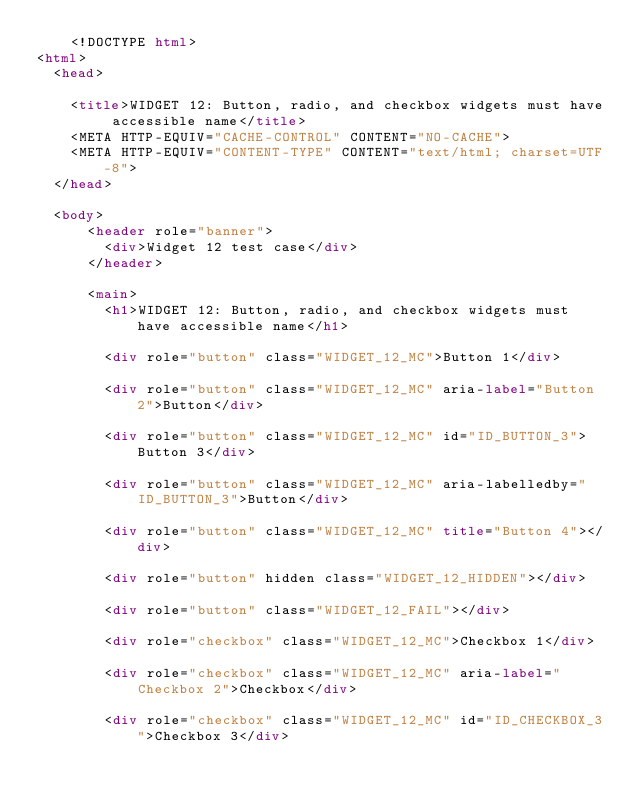<code> <loc_0><loc_0><loc_500><loc_500><_HTML_>    <!DOCTYPE html>
<html>
  <head>
    
    <title>WIDGET 12: Button, radio, and checkbox widgets must have accessible name</title>
    <META HTTP-EQUIV="CACHE-CONTROL" CONTENT="NO-CACHE">
    <META HTTP-EQUIV="CONTENT-TYPE" CONTENT="text/html; charset=UTF-8">
  </head>

  <body>
      <header role="banner">
        <div>Widget 12 test case</div>
      </header>
      
      <main>
        <h1>WIDGET 12: Button, radio, and checkbox widgets must have accessible name</h1>
        
        <div role="button" class="WIDGET_12_MC">Button 1</div>

        <div role="button" class="WIDGET_12_MC" aria-label="Button 2">Button</div>
        
        <div role="button" class="WIDGET_12_MC" id="ID_BUTTON_3">Button 3</div> 

        <div role="button" class="WIDGET_12_MC" aria-labelledby="ID_BUTTON_3">Button</div>

        <div role="button" class="WIDGET_12_MC" title="Button 4"></div>                                  

        <div role="button" hidden class="WIDGET_12_HIDDEN"></div>

        <div role="button" class="WIDGET_12_FAIL"></div>  
      
        <div role="checkbox" class="WIDGET_12_MC">Checkbox 1</div>

        <div role="checkbox" class="WIDGET_12_MC" aria-label="Checkbox 2">Checkbox</div>
        
        <div role="checkbox" class="WIDGET_12_MC" id="ID_CHECKBOX_3">Checkbox 3</div> 
</code> 